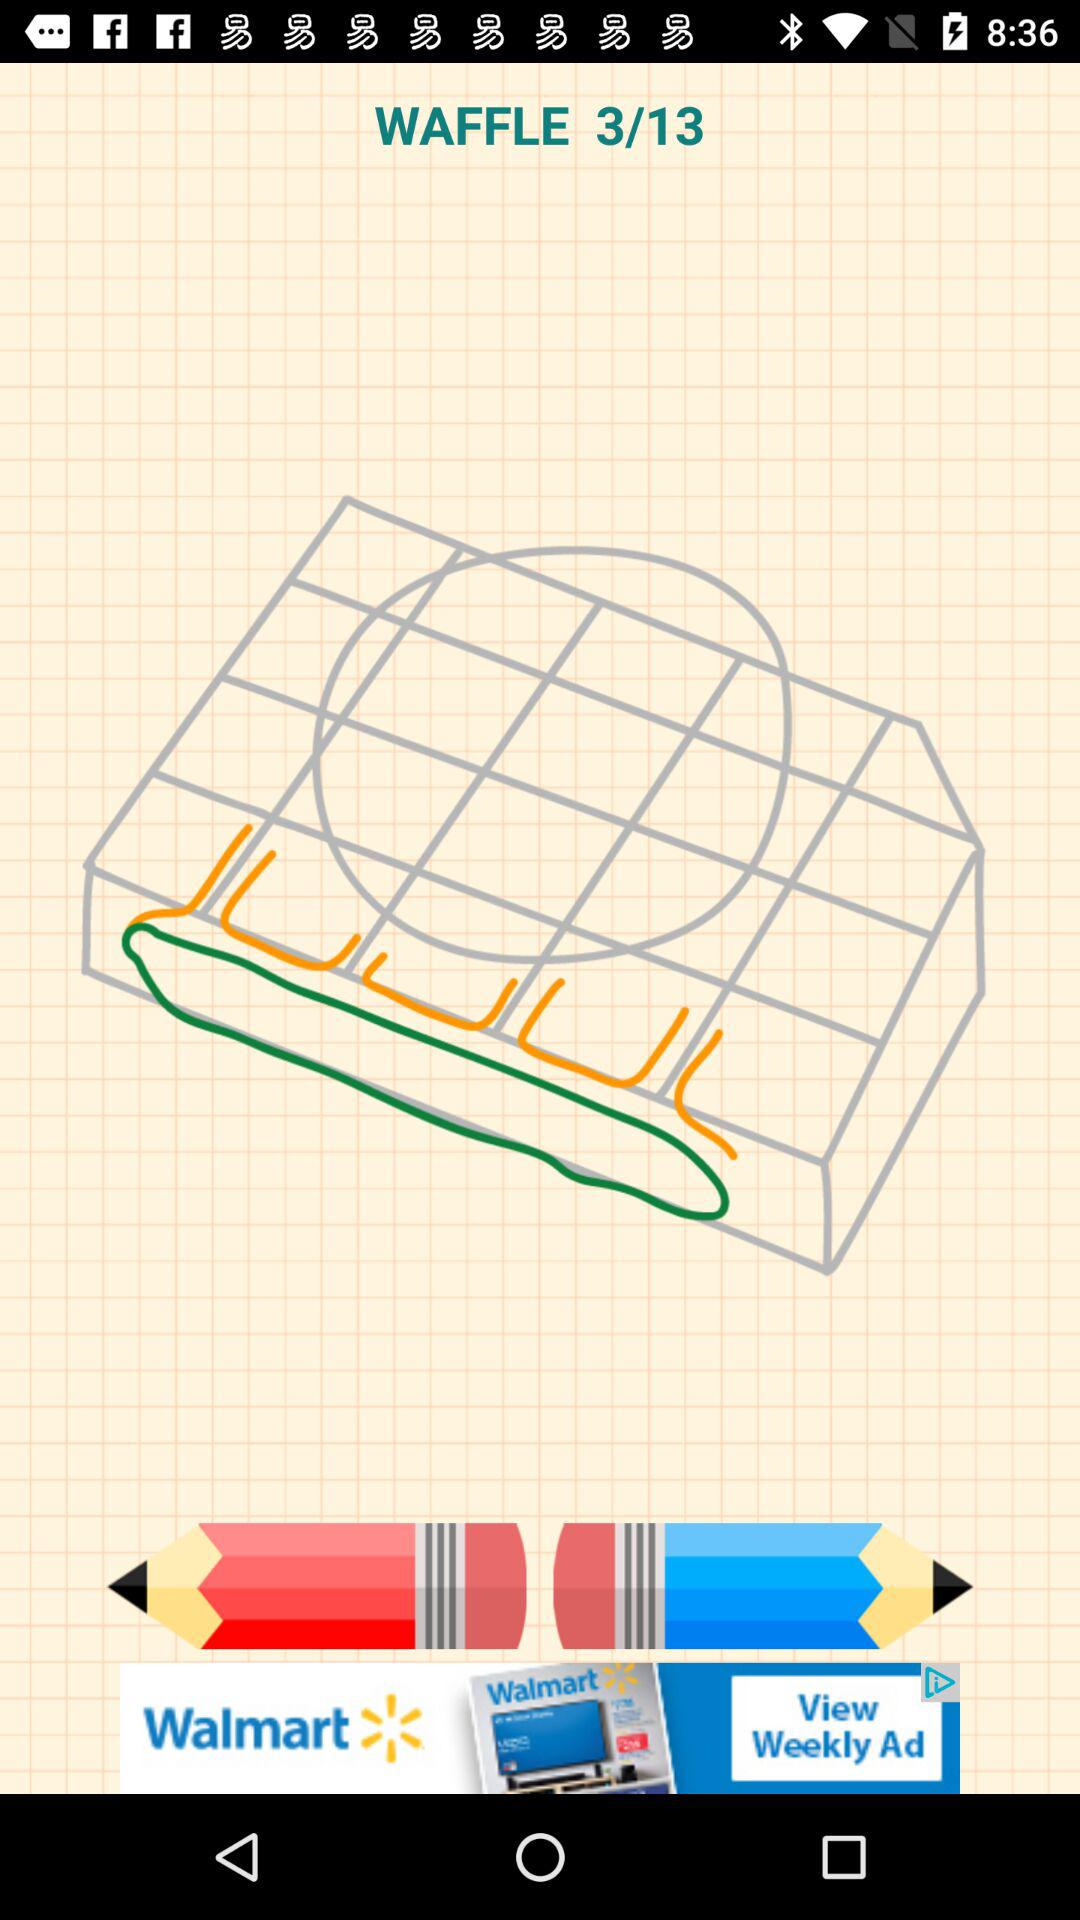What is the title of image 4?
When the provided information is insufficient, respond with <no answer>. <no answer> 